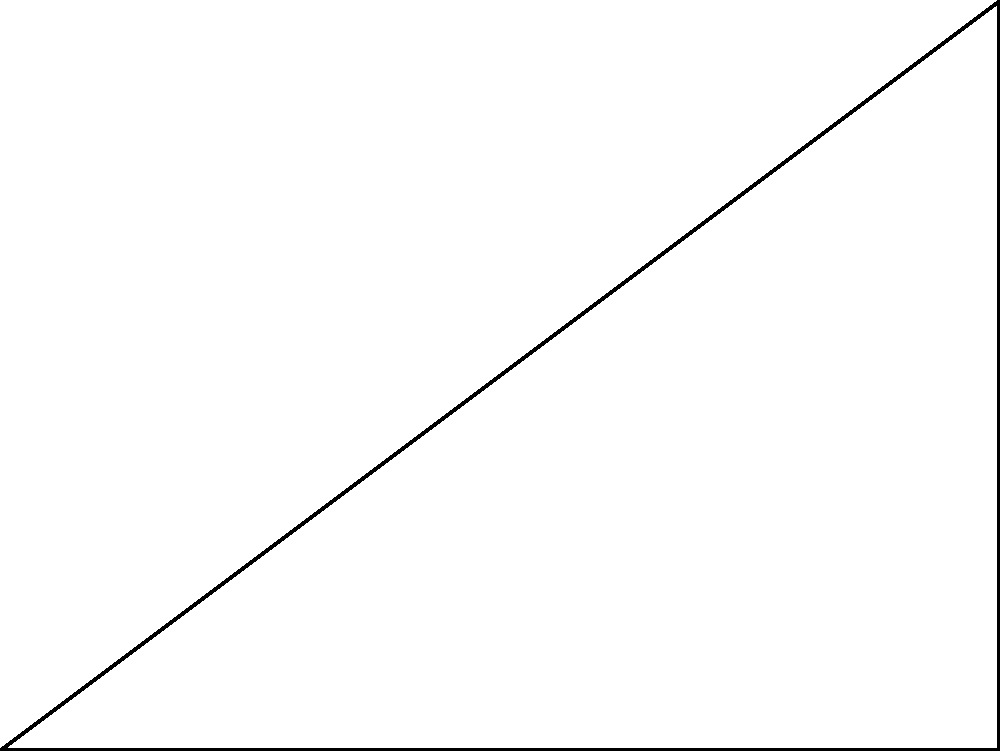In a recording studio, a microphone is placed at point O, 4 meters away from a wall (point A). A sound source is located at point B, 3 meters above point A on the wall. To minimize interference from reflections, the microphone needs to be positioned so that the angle $\theta$ between the direct path (OB) and the reflected path (OA) is 90°. Calculate the distance between the microphone and the sound source (length OB) to achieve this optimal placement. Let's approach this step-by-step:

1) We have a right-angled triangle OAB, where:
   - OA = 4m (given)
   - AB = 3m (given)
   - Angle AOB = 90° (required for optimal placement)

2) We need to find OB. This is a perfect scenario to use the Pythagorean theorem.

3) The Pythagorean theorem states that in a right-angled triangle:
   $a^2 + b^2 = c^2$
   where c is the hypotenuse (the longest side, opposite the right angle)

4) In our case:
   $OA^2 + AB^2 = OB^2$

5) Substituting the known values:
   $4^2 + 3^2 = OB^2$

6) Simplifying:
   $16 + 9 = OB^2$
   $25 = OB^2$

7) Taking the square root of both sides:
   $\sqrt{25} = OB$
   $5 = OB$

Therefore, the distance between the microphone and the sound source (OB) should be 5 meters.
Answer: 5 meters 